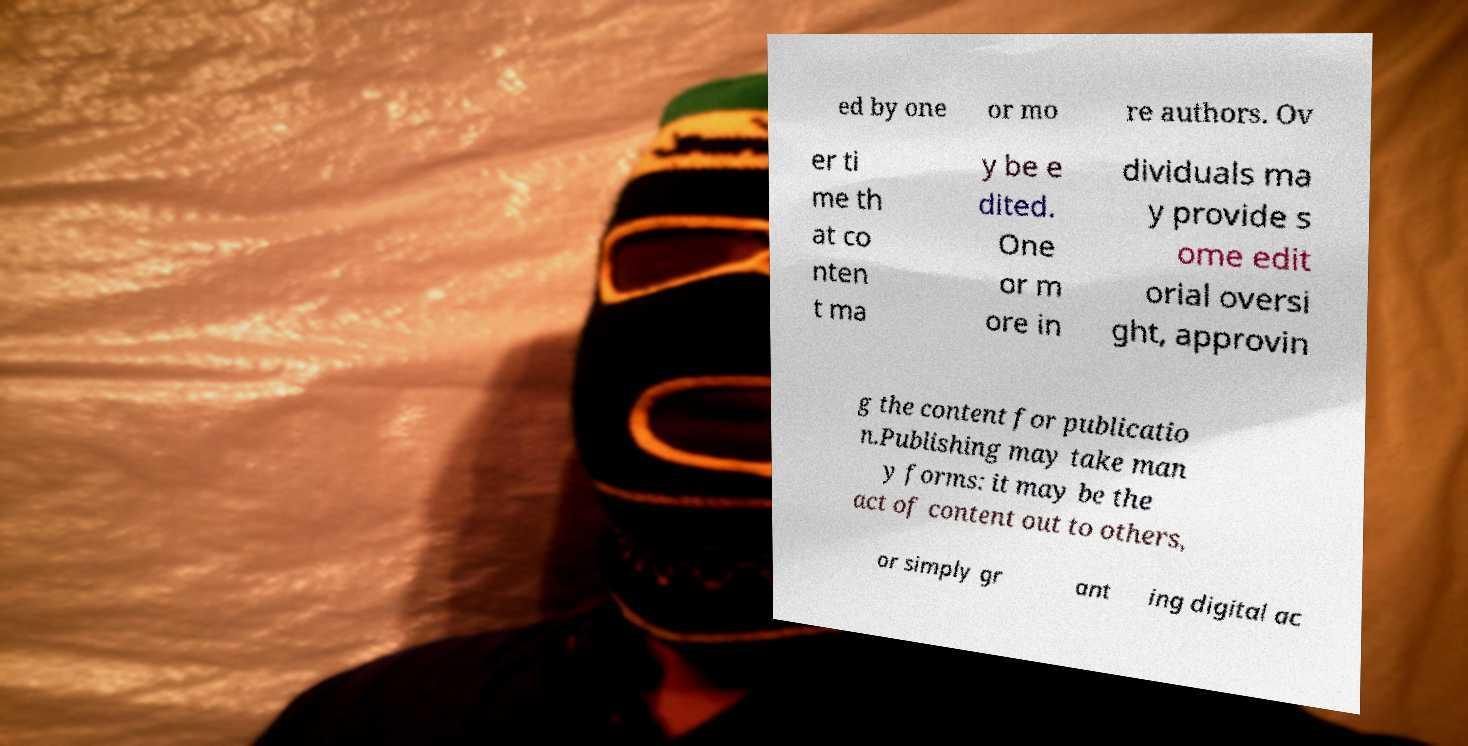There's text embedded in this image that I need extracted. Can you transcribe it verbatim? ed by one or mo re authors. Ov er ti me th at co nten t ma y be e dited. One or m ore in dividuals ma y provide s ome edit orial oversi ght, approvin g the content for publicatio n.Publishing may take man y forms: it may be the act of content out to others, or simply gr ant ing digital ac 